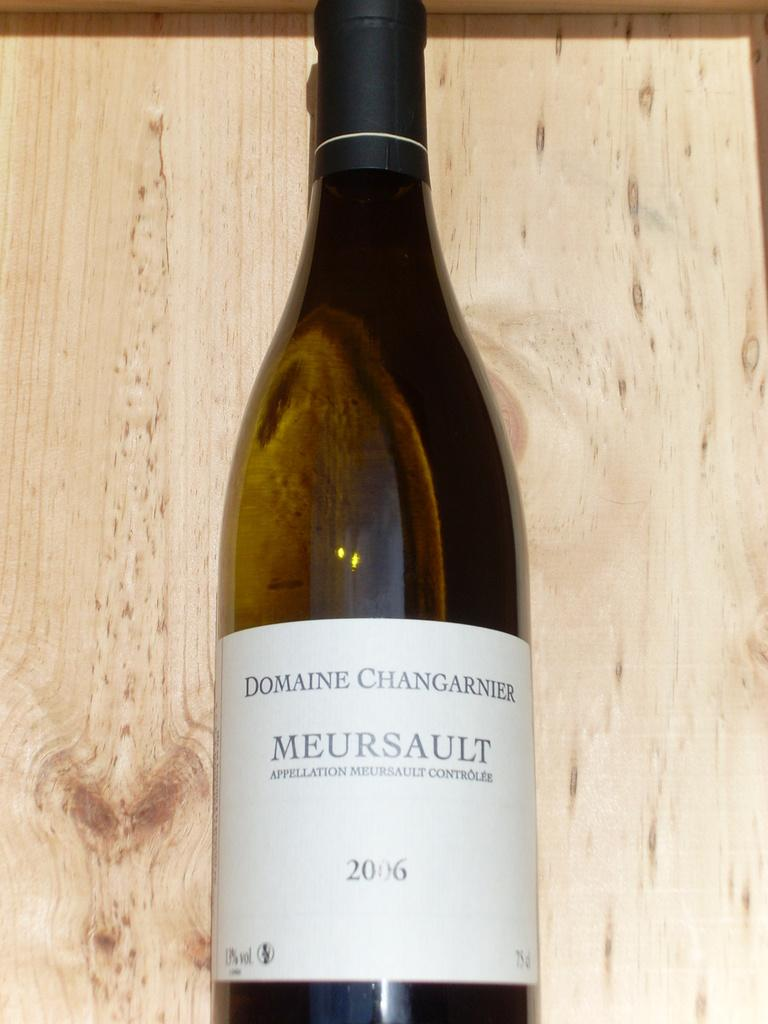Provide a one-sentence caption for the provided image. A bottle of Domaine Changarnier Meursault from 2006. 